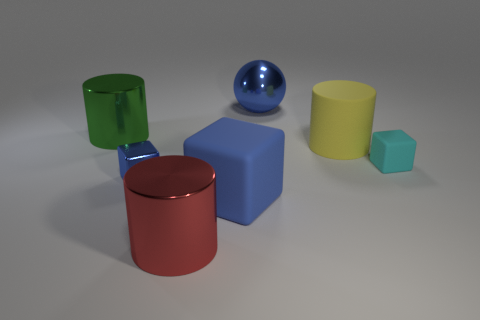Subtract 1 cylinders. How many cylinders are left? 2 Add 1 small cyan things. How many objects exist? 8 Subtract all cylinders. How many objects are left? 4 Add 6 small cyan objects. How many small cyan objects are left? 7 Add 2 large matte things. How many large matte things exist? 4 Subtract 0 cyan spheres. How many objects are left? 7 Subtract all large spheres. Subtract all red shiny things. How many objects are left? 5 